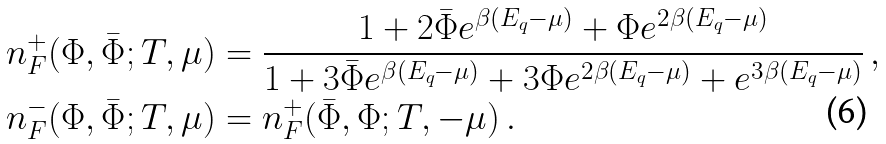Convert formula to latex. <formula><loc_0><loc_0><loc_500><loc_500>n _ { F } ^ { + } ( \Phi , { \bar { \Phi } } ; T , \mu ) & = \frac { 1 + 2 { \bar { \Phi } } e ^ { \beta ( E _ { q } - \mu ) } + \Phi e ^ { 2 \beta ( E _ { q } - \mu ) } } { 1 + 3 { \bar { \Phi } } e ^ { \beta ( E _ { q } - \mu ) } + 3 \Phi e ^ { 2 \beta ( E _ { q } - \mu ) } + e ^ { 3 \beta ( E _ { q } - \mu ) } } \, , \\ n _ { F } ^ { - } ( \Phi , { \bar { \Phi } } ; T , \mu ) & = n _ { F } ^ { + } ( { \bar { \Phi } } , \Phi ; T , - \mu ) \, .</formula> 